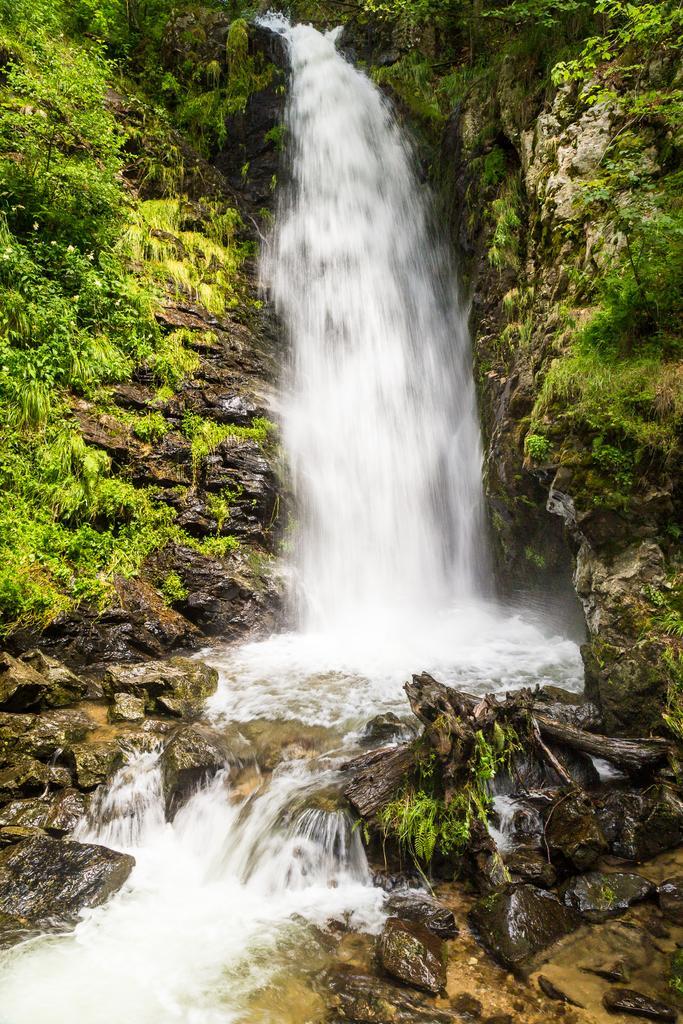In one or two sentences, can you explain what this image depicts? In this image we can see the waterfalls. There are mountains and trees. 